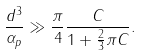Convert formula to latex. <formula><loc_0><loc_0><loc_500><loc_500>\frac { d ^ { 3 } } { \alpha _ { p } } \gg \frac { \pi } 4 \frac { C } { 1 + \frac { 2 } { 3 } \pi C } .</formula> 